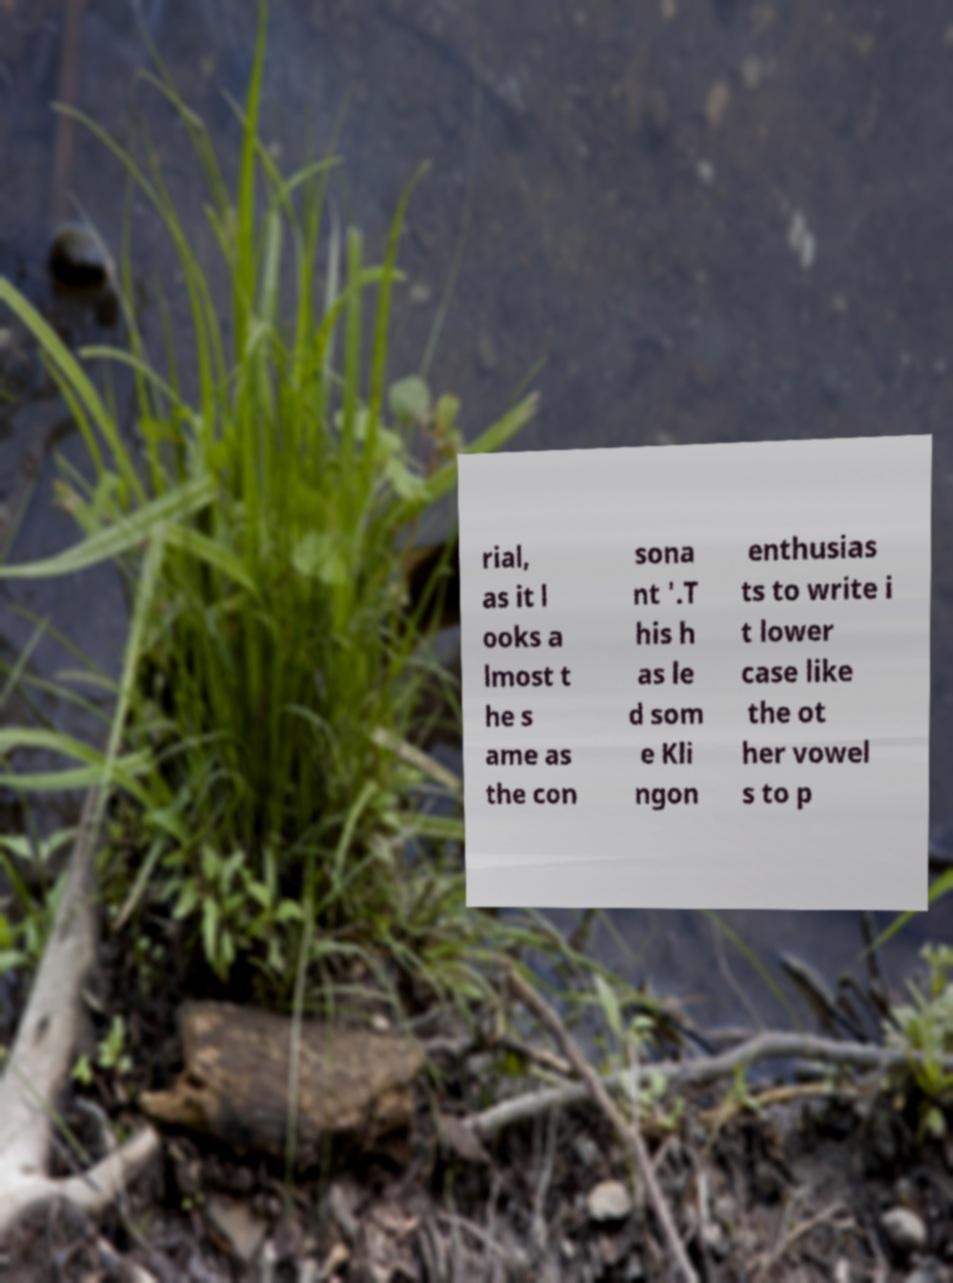Could you assist in decoding the text presented in this image and type it out clearly? rial, as it l ooks a lmost t he s ame as the con sona nt '.T his h as le d som e Kli ngon enthusias ts to write i t lower case like the ot her vowel s to p 